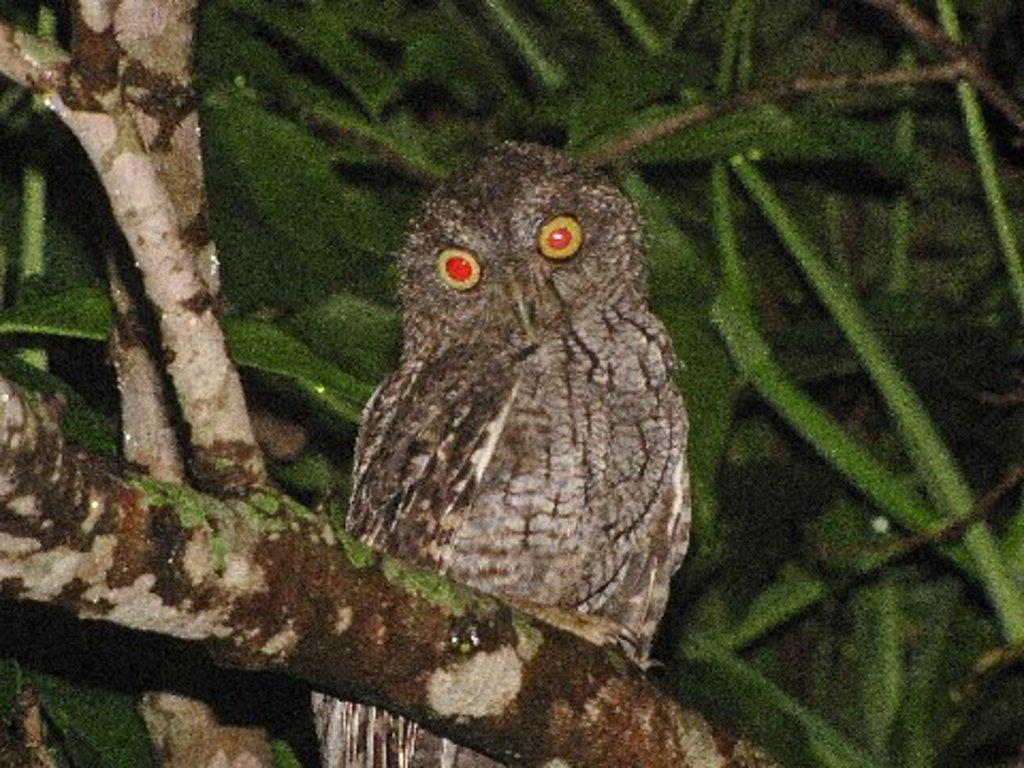What is the main subject of the image? There is an owl in the center of the image. What can be seen in the background of the image? There are trees in the background of the image. What type of leather is the owl wearing in the image? The owl is not wearing any leather in the image; it is a bird and does not wear clothing. 